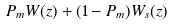<formula> <loc_0><loc_0><loc_500><loc_500>P _ { m } W ( z ) + ( 1 - P _ { m } ) W _ { s } ( z )</formula> 